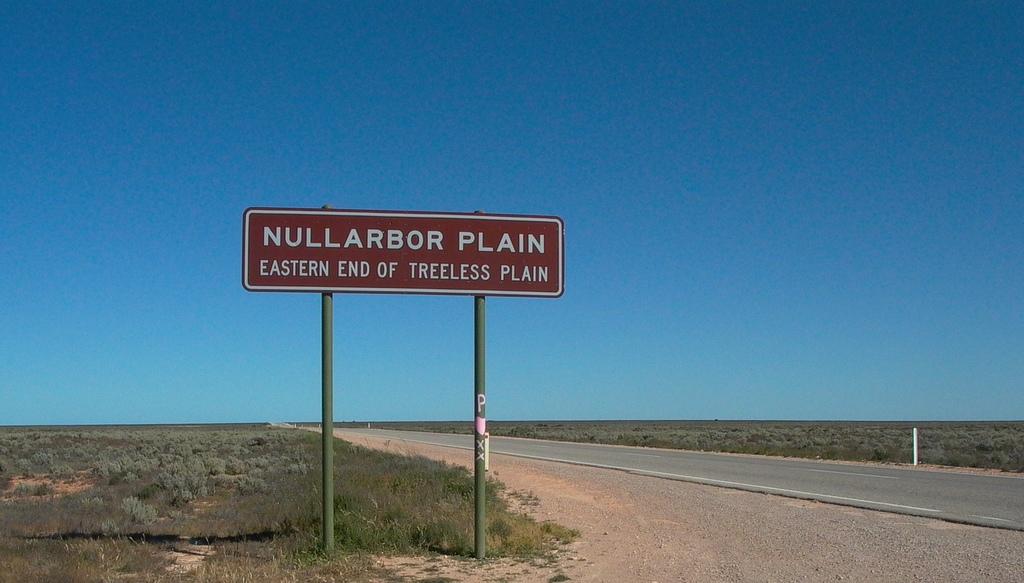What plain is of the eastern end?
Keep it short and to the point. Nullarbor. 